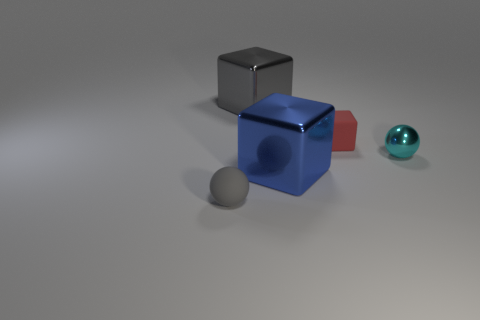What number of other objects are the same color as the matte sphere?
Your answer should be compact. 1. Do the small rubber sphere and the large metal cube behind the big blue metallic object have the same color?
Provide a short and direct response. Yes. What is the block that is behind the big blue metal object and to the left of the tiny red matte object made of?
Provide a succinct answer. Metal. What is the size of the cube that is the same color as the tiny matte ball?
Keep it short and to the point. Large. Does the tiny rubber object behind the gray sphere have the same shape as the gray thing that is to the right of the gray rubber object?
Keep it short and to the point. Yes. Is there a ball?
Ensure brevity in your answer.  Yes. What is the color of the other big shiny thing that is the same shape as the gray metal object?
Make the answer very short. Blue. There is a ball that is the same size as the gray matte object; what color is it?
Your response must be concise. Cyan. Are the blue cube and the cyan sphere made of the same material?
Your answer should be compact. Yes. How many big cubes have the same color as the tiny matte ball?
Make the answer very short. 1. 